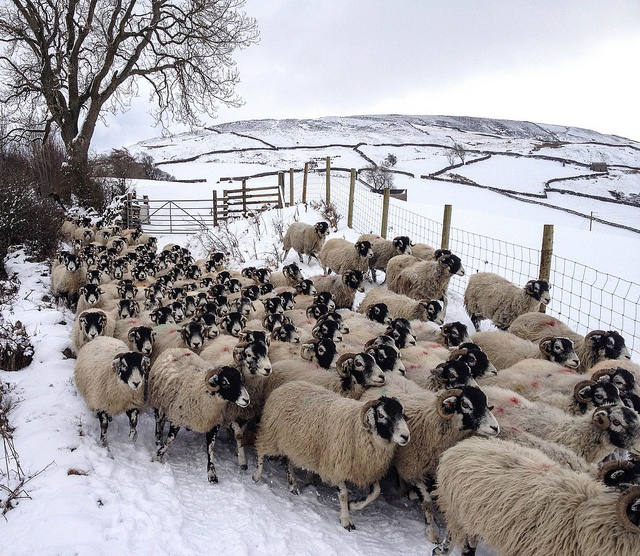Describe the objects in this image and their specific colors. I can see sheep in lavender, black, darkgray, and gray tones, sheep in lavender, darkgray, and gray tones, sheep in lavender, gray, and darkgray tones, sheep in lavender, black, gray, and darkgray tones, and sheep in lavender, gray, black, and darkgray tones in this image. 